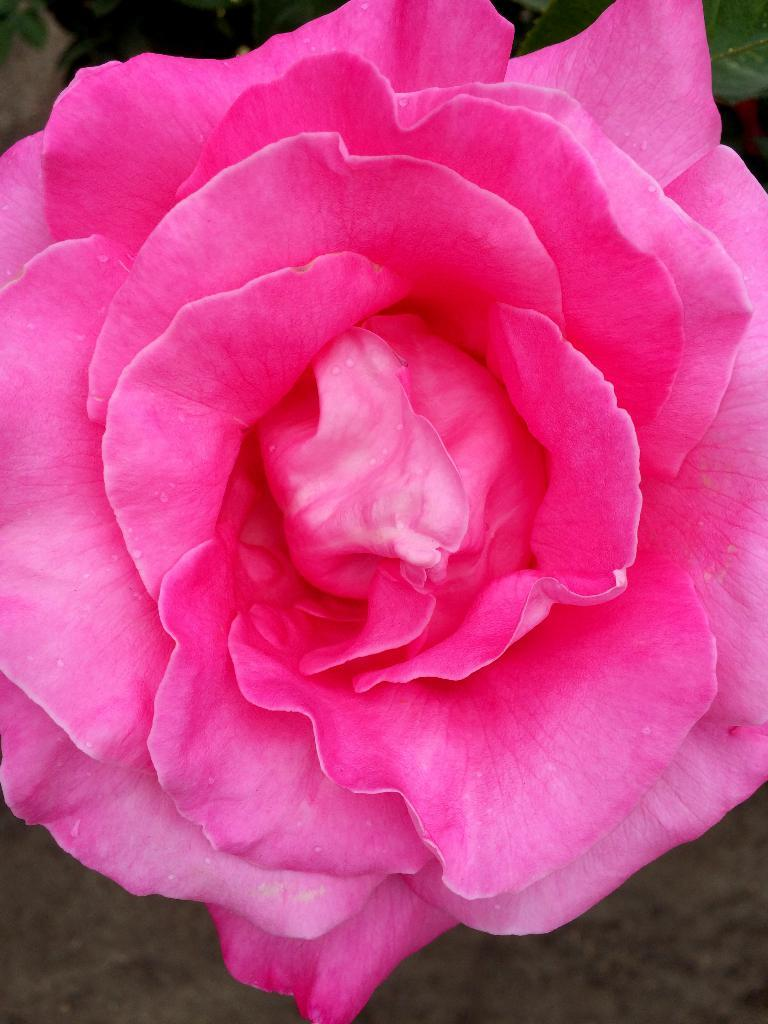What type of flower is in the image? There is a pink rose flower in the image. Can you describe the background of the image? The background of the image is blurry. What part of the flower is visible in the image? The petals of the flower are visible in the image. How many dogs are jumping in the image? There are no dogs or jumping depicted in the image; it features a pink rose flower with a blurry background. 